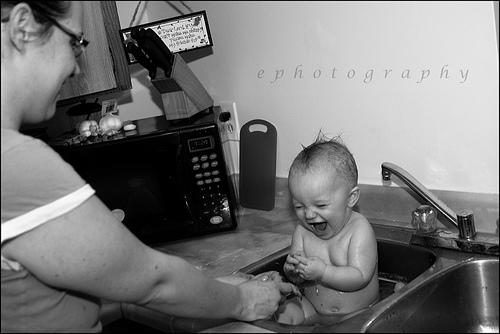Who is most likely bathing the baby? mother 